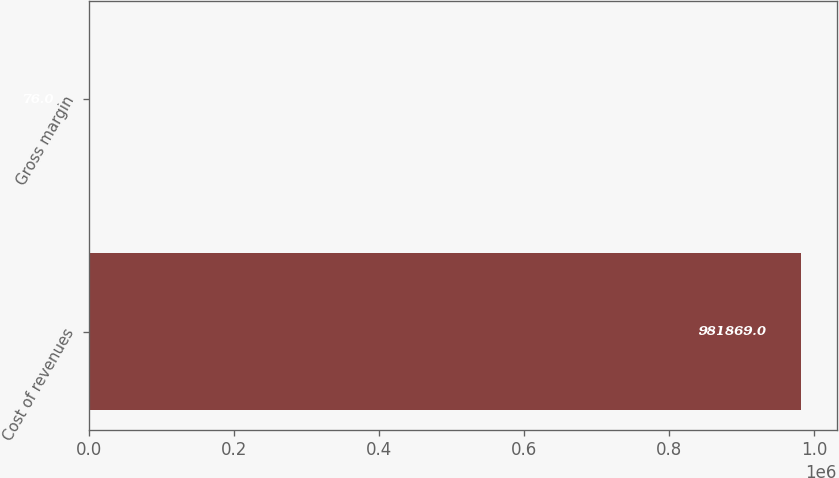Convert chart to OTSL. <chart><loc_0><loc_0><loc_500><loc_500><bar_chart><fcel>Cost of revenues<fcel>Gross margin<nl><fcel>981869<fcel>76<nl></chart> 